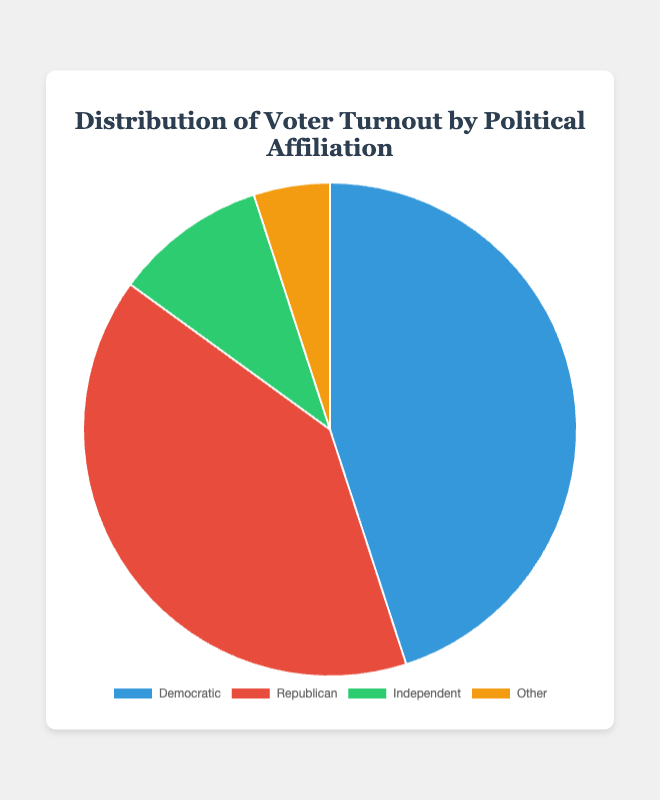What percentage of the voter turnout belongs to Democratic and Independent combined? To find the combined voter turnout for Democratic and Independent, add their respective percentages: 45% (Democratic) + 10% (Independent) = 55%.
Answer: 55% Which political affiliation has the lowest voter turnout? Looking at the percentages, 'Other' has the lowest voter turnout with 5%.
Answer: Other How much higher is the Democratic voter turnout compared to the Republican voter turnout? Subtract the Republican voter turnout (40%) from the Democratic voter turnout (45%): 45% - 40% = 5%.
Answer: 5% What is the ratio of Democratic to Other voter turnout? Divide the Democratic voter turnout (45%) by the Other voter turnout (5%): 45 / 5 = 9.
Answer: 9 Which political affiliation has the second-highest voter turnout and what is that percentage? The political affiliation with the second-highest voter turnout is Republican with 40%.
Answer: Republican, 40% How does the Democratic voter turnout compare to the combined turnout of Independent and Other? Add the turnout of Independent (10%) and Other (5%): 10% + 5% = 15%. Compare it to the Democratic turnout (45%) and see that Democratic is higher: 45% - 15% = 30%.
Answer: Democratic is higher by 30% What percentage of the total voter turnout is attributed to groups other than Democratic and Republican? Add the percentages of Independent (10%) and Other (5%): 10% + 5% = 15%.
Answer: 15% What is the difference in voter turnout between Independent and Other? Subtract the Other voter turnout (5%) from Independent (10%): 10% - 5% = 5%.
Answer: 5% Which political affiliation has a voter turnout that is twice another group's turnout? The Democratic turnout (45%) is approximately twice the Republican turnout (40%), but more precisely, the Independent turnout (10%) is twice the Other turnout (5%).
Answer: Independent to Other 